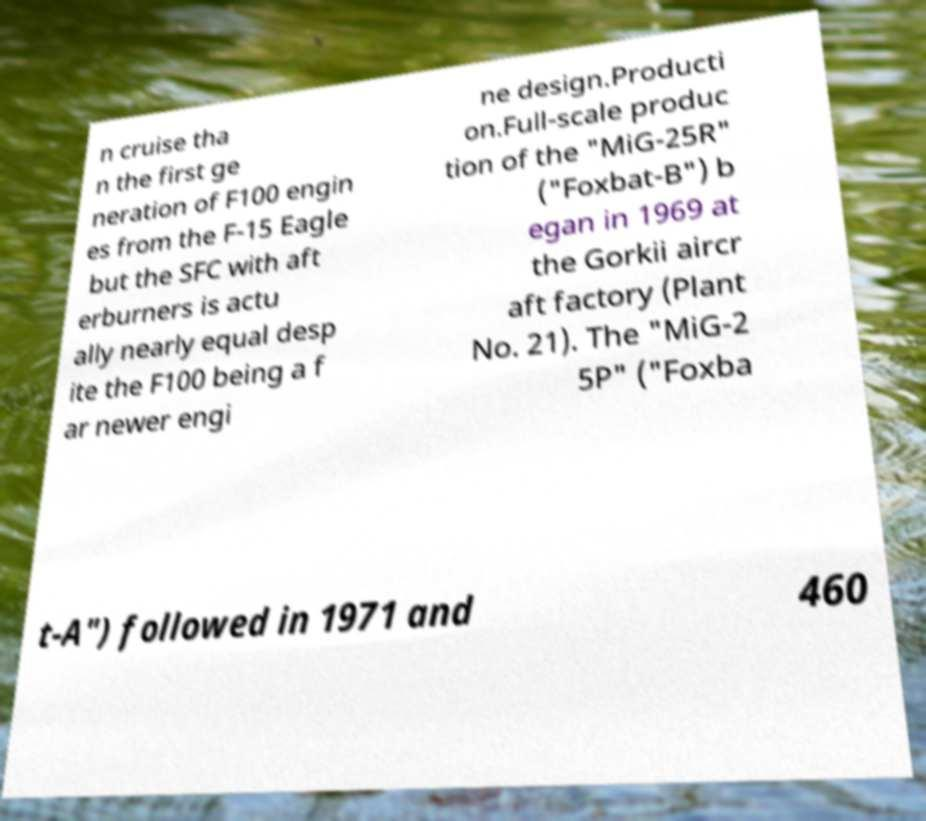There's text embedded in this image that I need extracted. Can you transcribe it verbatim? n cruise tha n the first ge neration of F100 engin es from the F-15 Eagle but the SFC with aft erburners is actu ally nearly equal desp ite the F100 being a f ar newer engi ne design.Producti on.Full-scale produc tion of the "MiG-25R" ("Foxbat-B") b egan in 1969 at the Gorkii aircr aft factory (Plant No. 21). The "MiG-2 5P" ("Foxba t-A") followed in 1971 and 460 